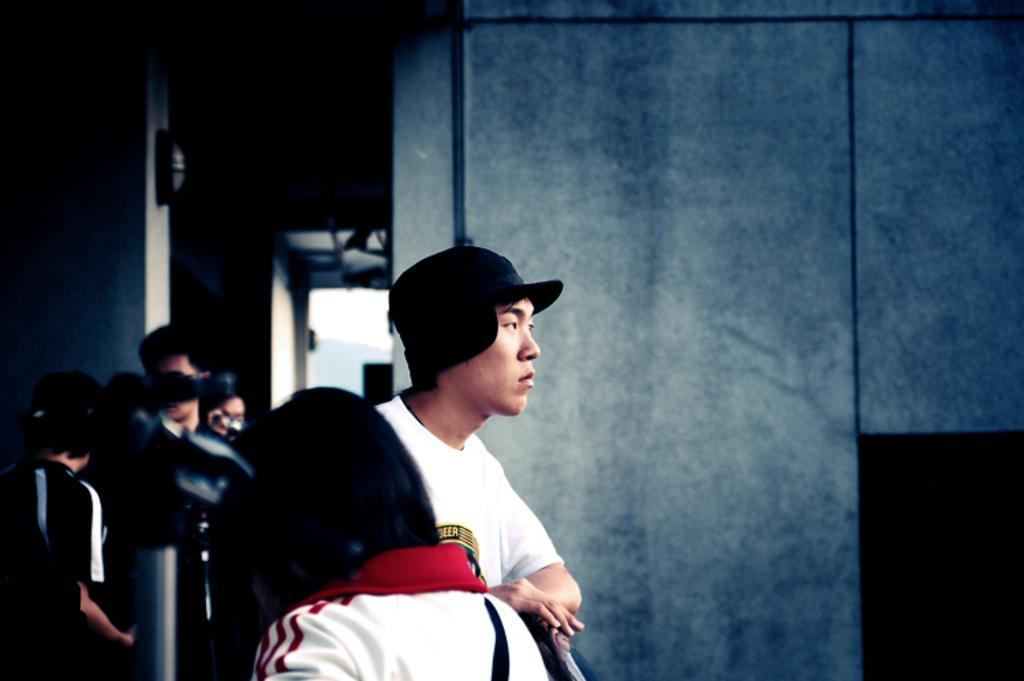Who or what is present in the image? There are people in the image. What is the background of the image? There is a wall in the image. What object can be seen in the image? There is a rod in the image. How many hands are visible in the image? There is no specific mention of hands in the image, so it is not possible to determine the number of hands visible. 